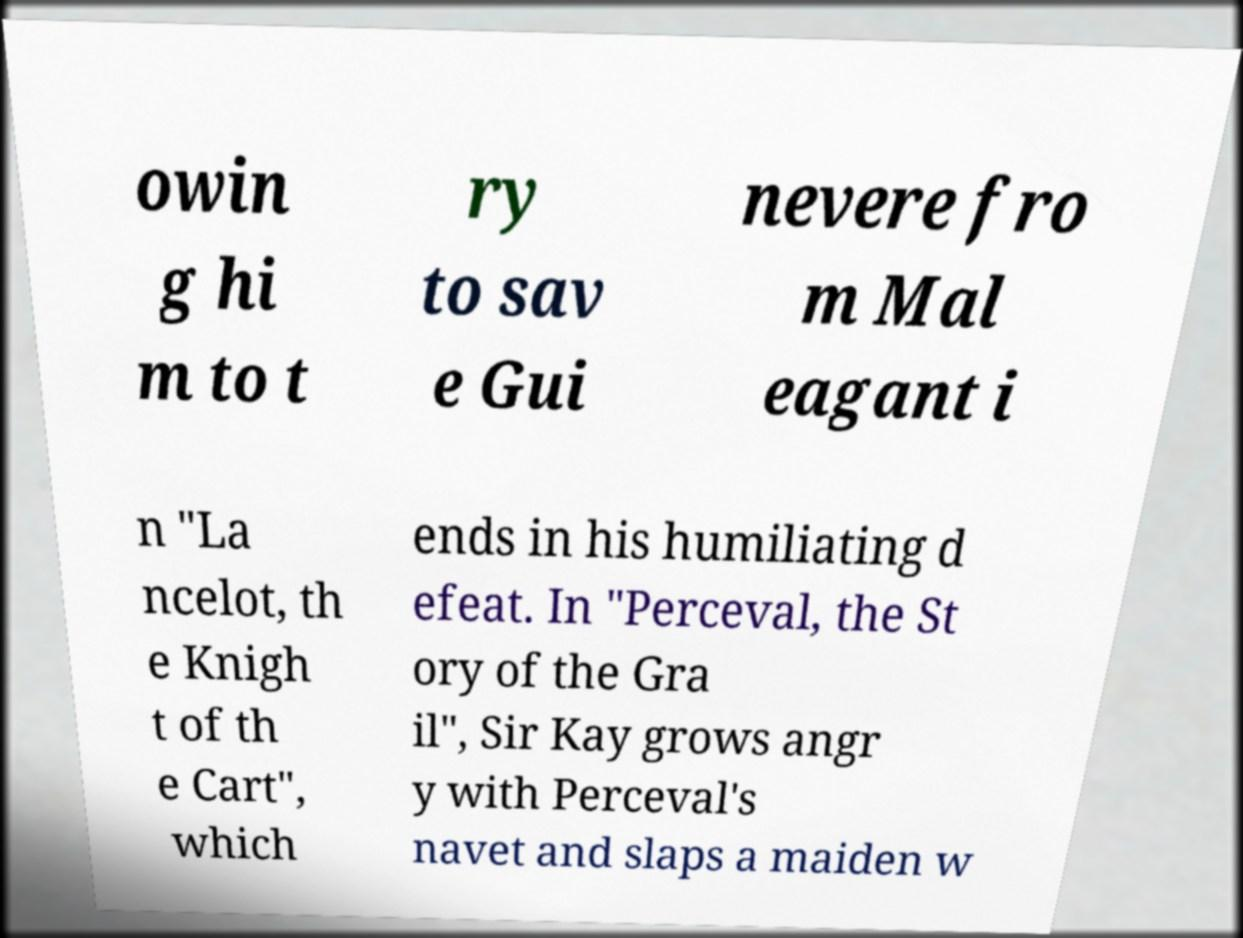What messages or text are displayed in this image? I need them in a readable, typed format. owin g hi m to t ry to sav e Gui nevere fro m Mal eagant i n "La ncelot, th e Knigh t of th e Cart", which ends in his humiliating d efeat. In "Perceval, the St ory of the Gra il", Sir Kay grows angr y with Perceval's navet and slaps a maiden w 